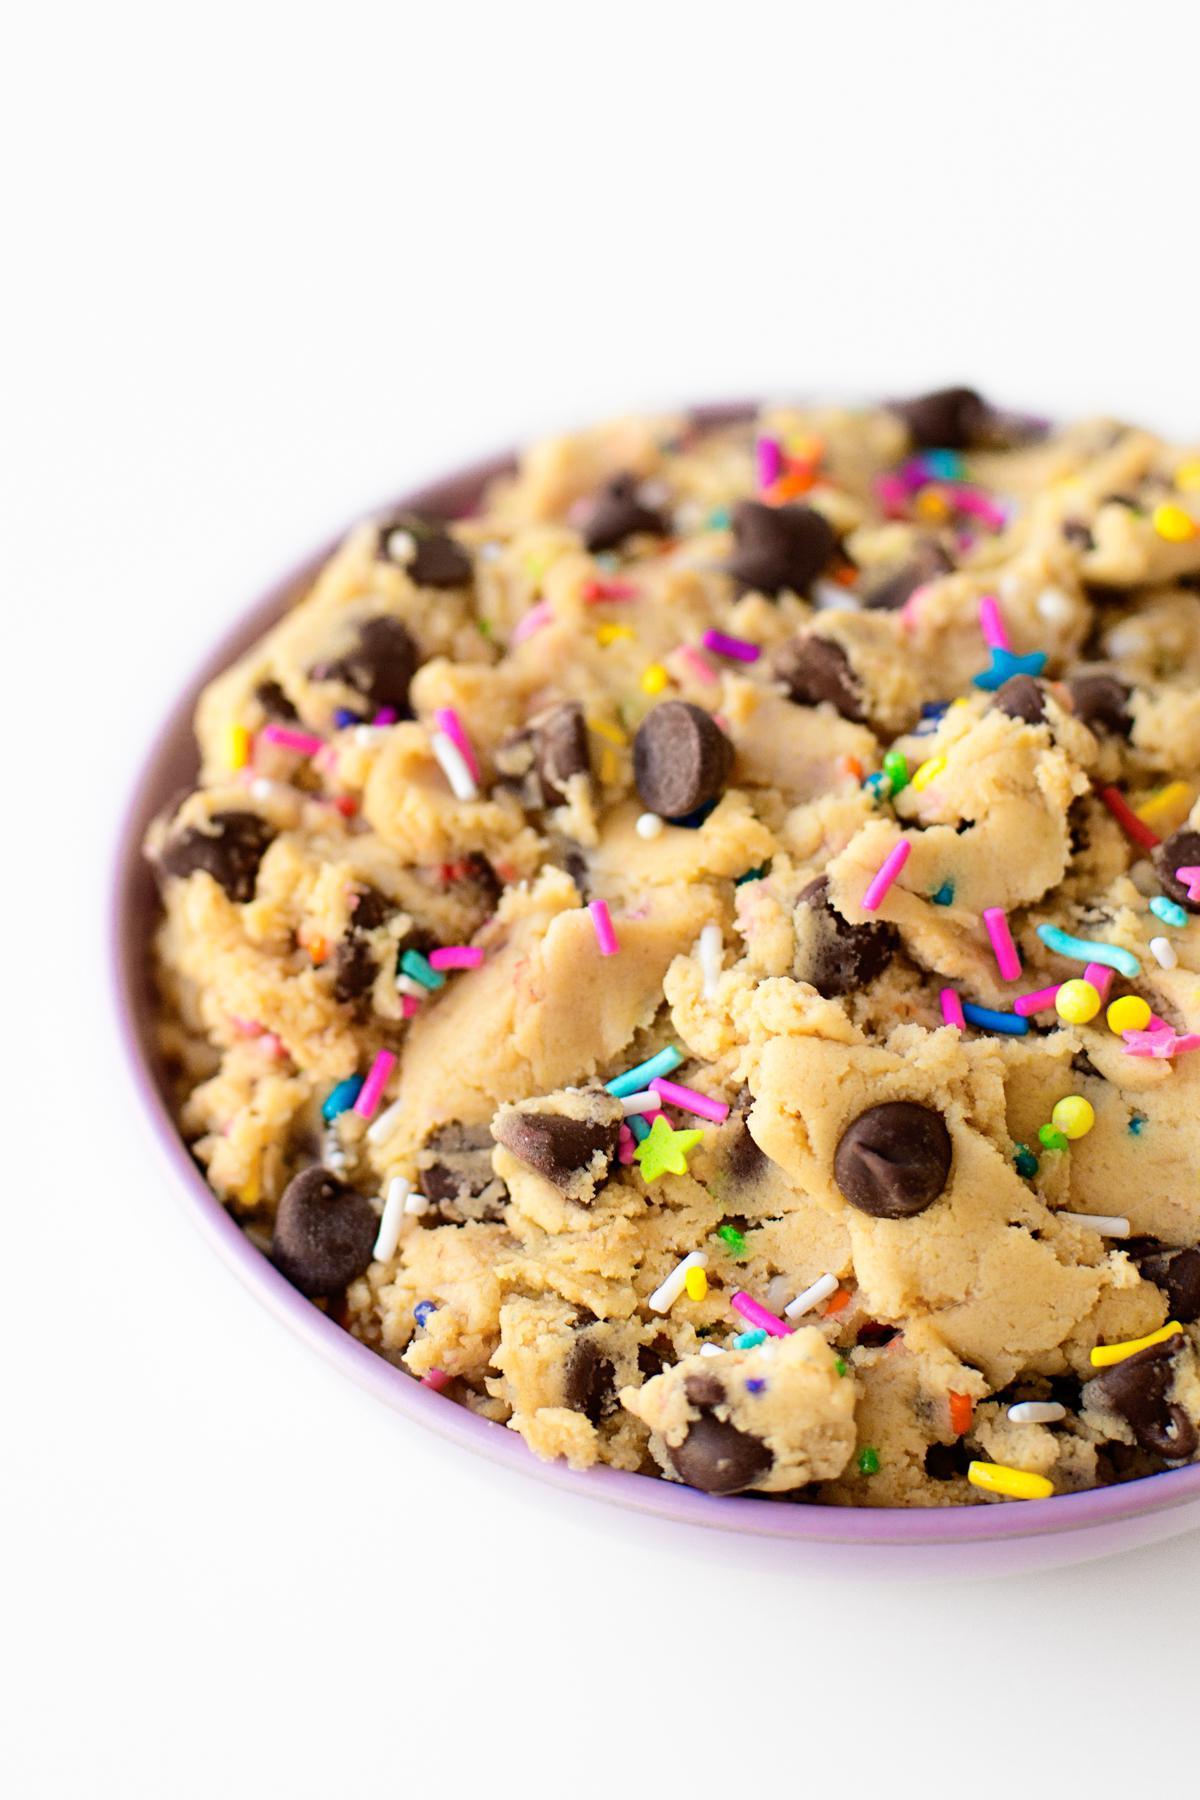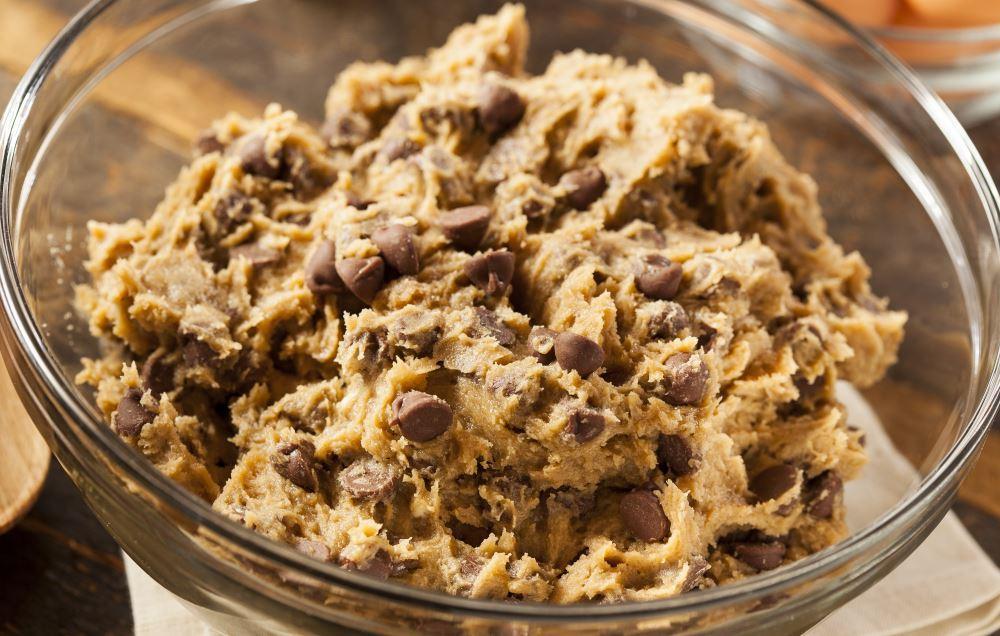The first image is the image on the left, the second image is the image on the right. Considering the images on both sides, is "There is a single glass bowl holding chocolate chip cookie dough." valid? Answer yes or no. Yes. The first image is the image on the left, the second image is the image on the right. For the images shown, is this caption "A spoon is laying on the table." true? Answer yes or no. No. 